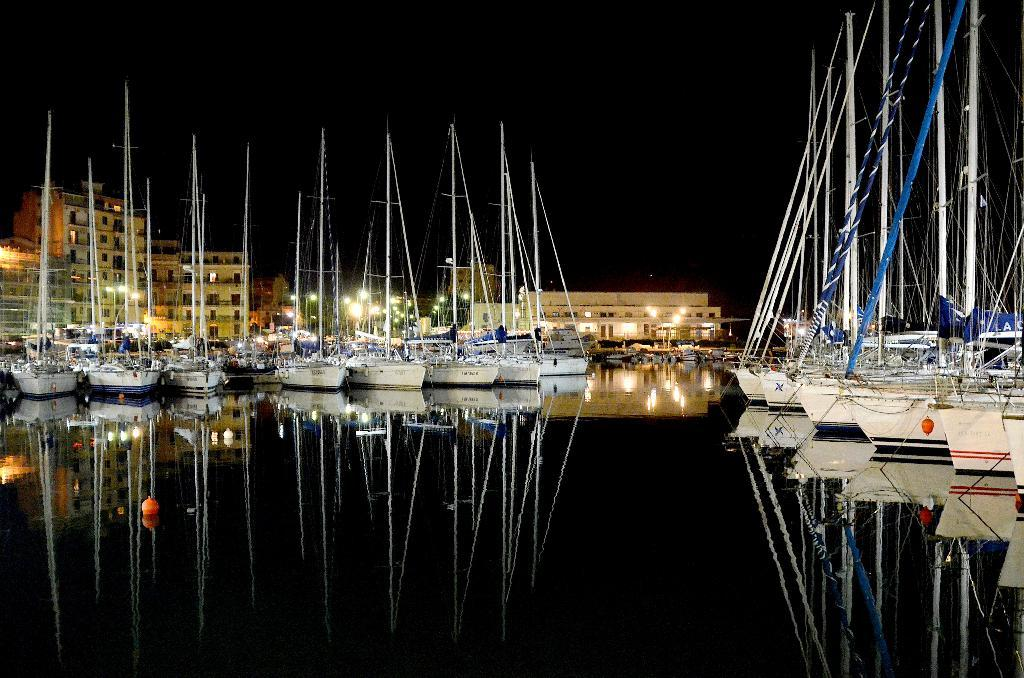What is positioned above the water in the image? There are boats above the water in the image. What can be seen in the background of the image? There are buildings and lights in the background. How would you describe the sky in the image? The sky is dark in the image. What is visible on the water's surface? There is a reflection of buildings, lights, and boats on the water. How many sticks are being held by the babies in the image? There are no babies or sticks present in the image. What shape does the heart have in the image? There is no heart present in the image. 